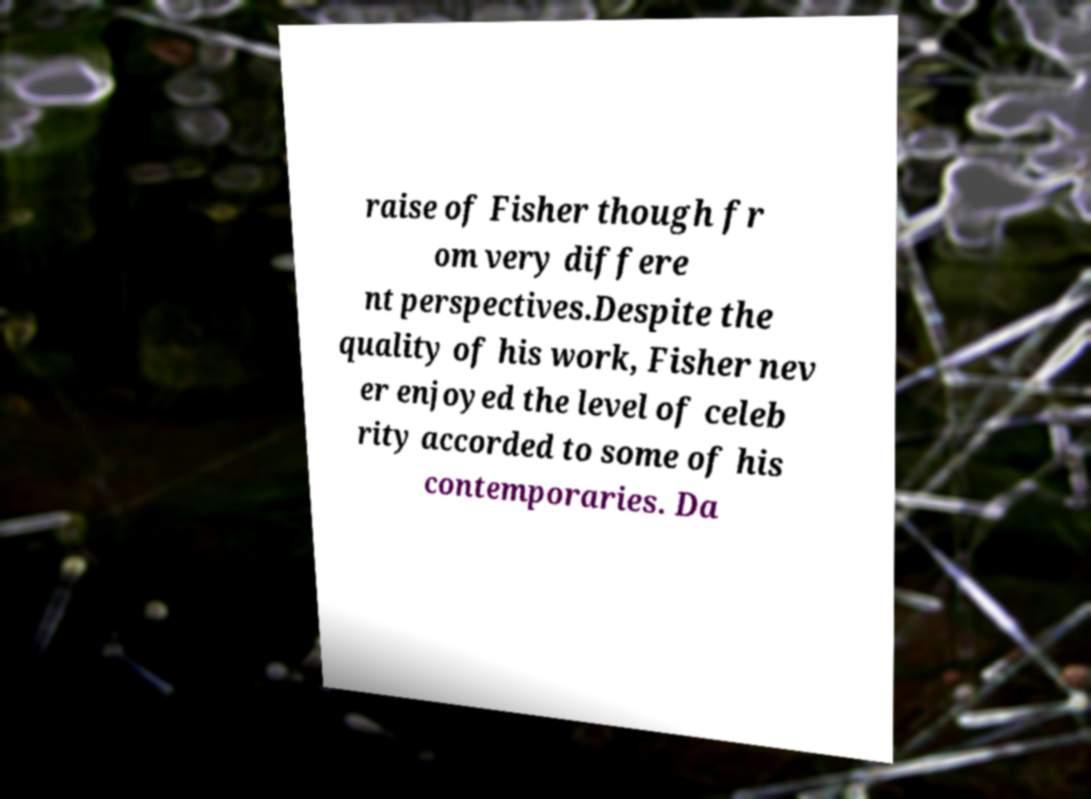For documentation purposes, I need the text within this image transcribed. Could you provide that? raise of Fisher though fr om very differe nt perspectives.Despite the quality of his work, Fisher nev er enjoyed the level of celeb rity accorded to some of his contemporaries. Da 